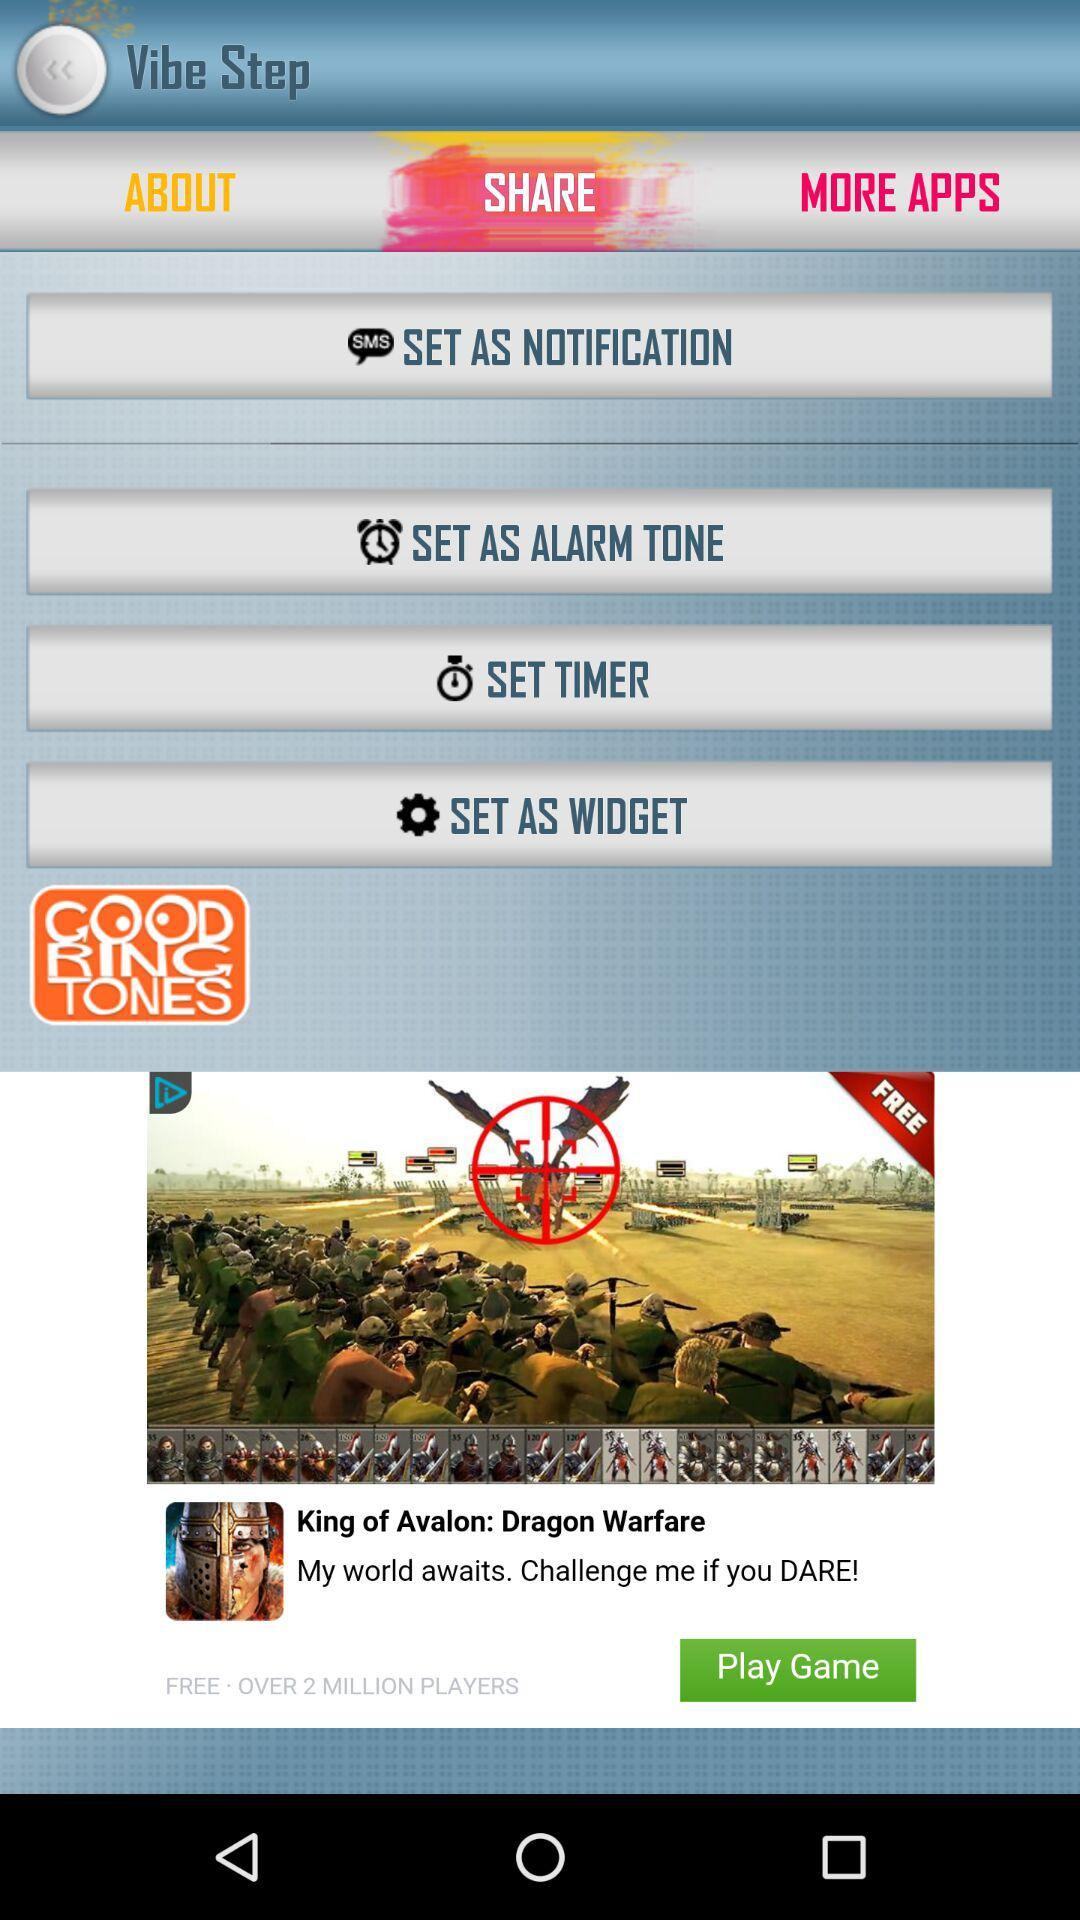Do we have share option?
When the provided information is insufficient, respond with <no answer>. <no answer> 